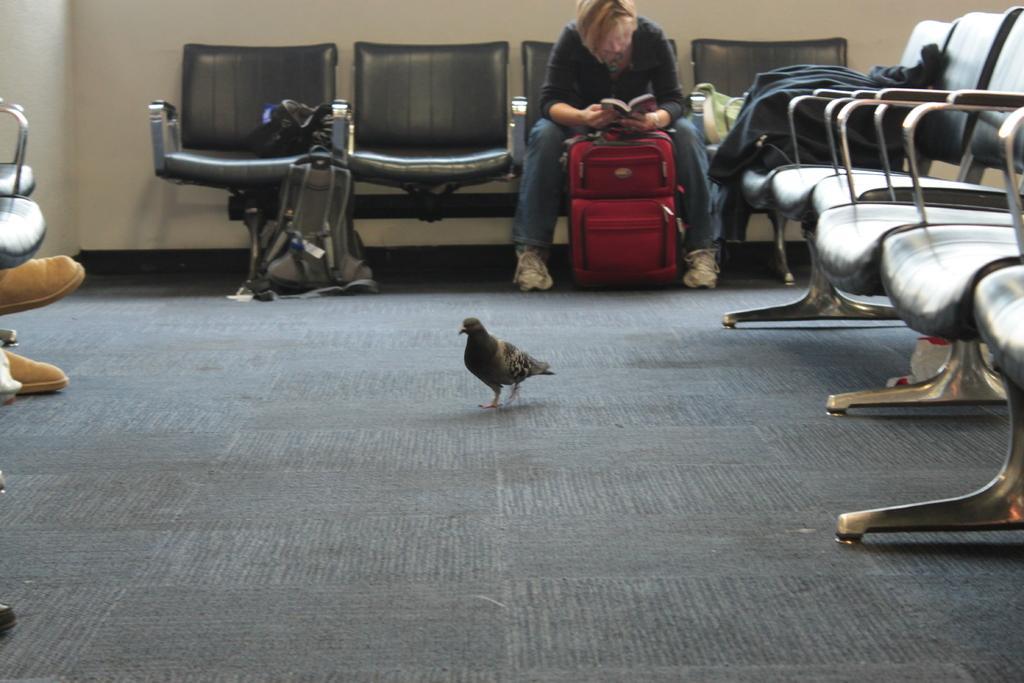How would you summarize this image in a sentence or two? In this image,there is a floor which is of gray color,In the right side there are some chairs,In the middle there is a bird,In the background there are some chairs and a woman sitting on the chair,In the left side there is a chair and a person sitting on the chair. 